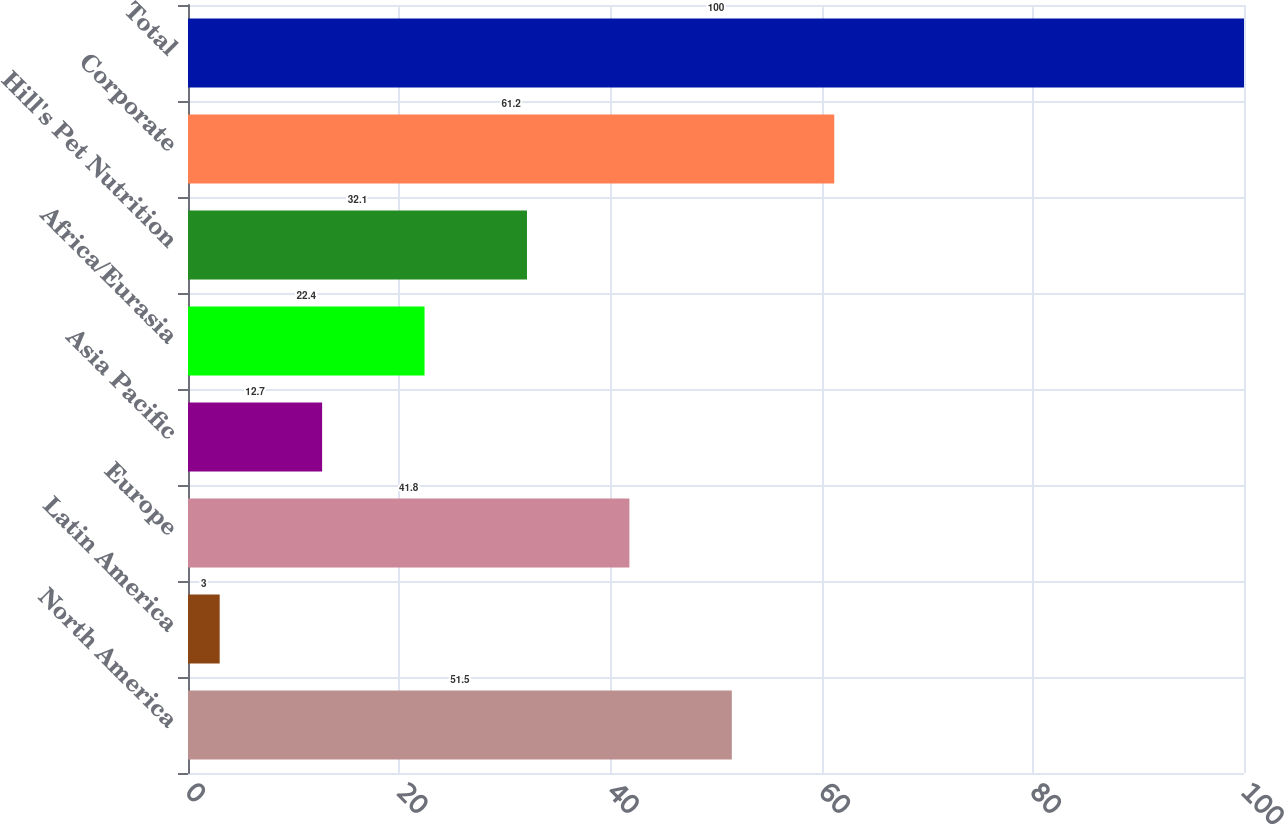Convert chart to OTSL. <chart><loc_0><loc_0><loc_500><loc_500><bar_chart><fcel>North America<fcel>Latin America<fcel>Europe<fcel>Asia Pacific<fcel>Africa/Eurasia<fcel>Hill's Pet Nutrition<fcel>Corporate<fcel>Total<nl><fcel>51.5<fcel>3<fcel>41.8<fcel>12.7<fcel>22.4<fcel>32.1<fcel>61.2<fcel>100<nl></chart> 